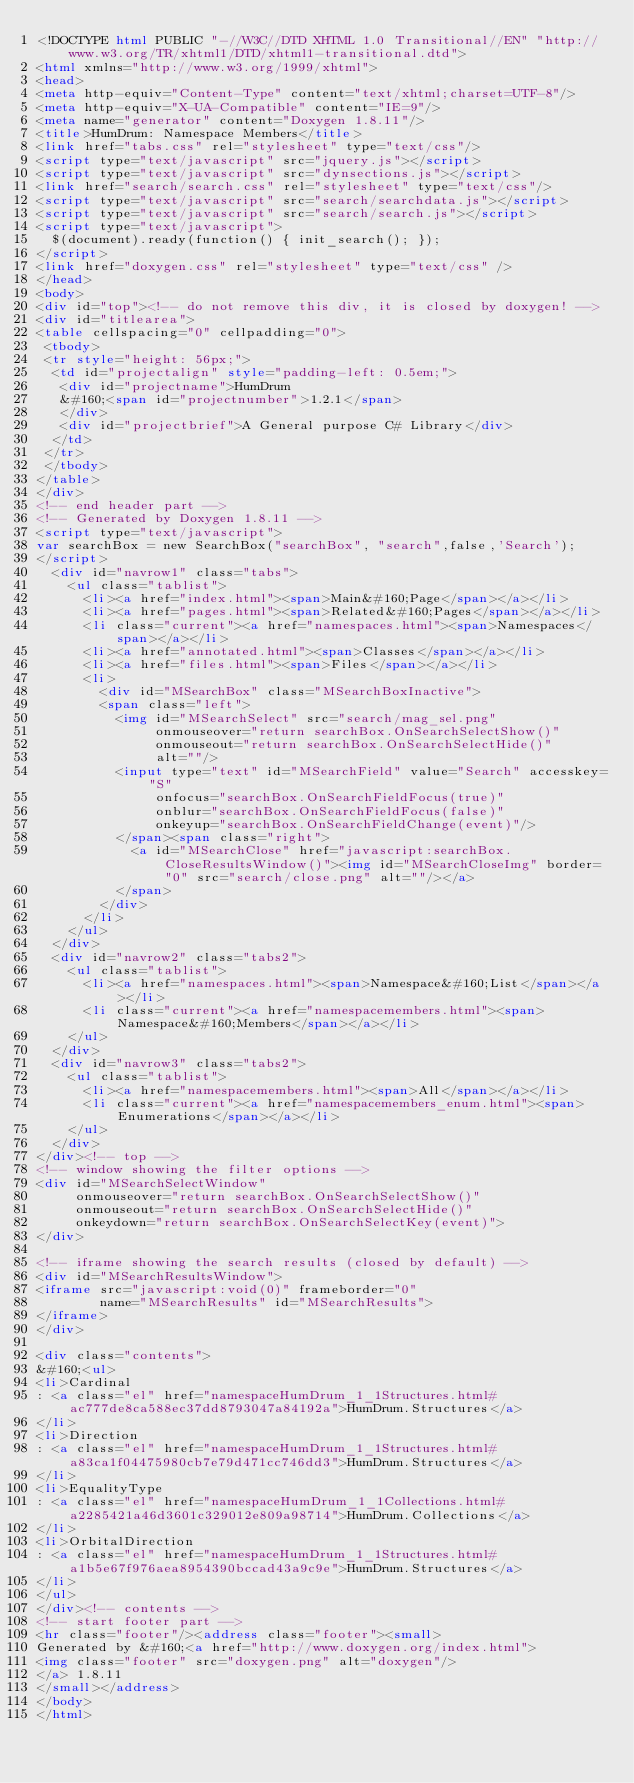Convert code to text. <code><loc_0><loc_0><loc_500><loc_500><_HTML_><!DOCTYPE html PUBLIC "-//W3C//DTD XHTML 1.0 Transitional//EN" "http://www.w3.org/TR/xhtml1/DTD/xhtml1-transitional.dtd">
<html xmlns="http://www.w3.org/1999/xhtml">
<head>
<meta http-equiv="Content-Type" content="text/xhtml;charset=UTF-8"/>
<meta http-equiv="X-UA-Compatible" content="IE=9"/>
<meta name="generator" content="Doxygen 1.8.11"/>
<title>HumDrum: Namespace Members</title>
<link href="tabs.css" rel="stylesheet" type="text/css"/>
<script type="text/javascript" src="jquery.js"></script>
<script type="text/javascript" src="dynsections.js"></script>
<link href="search/search.css" rel="stylesheet" type="text/css"/>
<script type="text/javascript" src="search/searchdata.js"></script>
<script type="text/javascript" src="search/search.js"></script>
<script type="text/javascript">
  $(document).ready(function() { init_search(); });
</script>
<link href="doxygen.css" rel="stylesheet" type="text/css" />
</head>
<body>
<div id="top"><!-- do not remove this div, it is closed by doxygen! -->
<div id="titlearea">
<table cellspacing="0" cellpadding="0">
 <tbody>
 <tr style="height: 56px;">
  <td id="projectalign" style="padding-left: 0.5em;">
   <div id="projectname">HumDrum
   &#160;<span id="projectnumber">1.2.1</span>
   </div>
   <div id="projectbrief">A General purpose C# Library</div>
  </td>
 </tr>
 </tbody>
</table>
</div>
<!-- end header part -->
<!-- Generated by Doxygen 1.8.11 -->
<script type="text/javascript">
var searchBox = new SearchBox("searchBox", "search",false,'Search');
</script>
  <div id="navrow1" class="tabs">
    <ul class="tablist">
      <li><a href="index.html"><span>Main&#160;Page</span></a></li>
      <li><a href="pages.html"><span>Related&#160;Pages</span></a></li>
      <li class="current"><a href="namespaces.html"><span>Namespaces</span></a></li>
      <li><a href="annotated.html"><span>Classes</span></a></li>
      <li><a href="files.html"><span>Files</span></a></li>
      <li>
        <div id="MSearchBox" class="MSearchBoxInactive">
        <span class="left">
          <img id="MSearchSelect" src="search/mag_sel.png"
               onmouseover="return searchBox.OnSearchSelectShow()"
               onmouseout="return searchBox.OnSearchSelectHide()"
               alt=""/>
          <input type="text" id="MSearchField" value="Search" accesskey="S"
               onfocus="searchBox.OnSearchFieldFocus(true)" 
               onblur="searchBox.OnSearchFieldFocus(false)" 
               onkeyup="searchBox.OnSearchFieldChange(event)"/>
          </span><span class="right">
            <a id="MSearchClose" href="javascript:searchBox.CloseResultsWindow()"><img id="MSearchCloseImg" border="0" src="search/close.png" alt=""/></a>
          </span>
        </div>
      </li>
    </ul>
  </div>
  <div id="navrow2" class="tabs2">
    <ul class="tablist">
      <li><a href="namespaces.html"><span>Namespace&#160;List</span></a></li>
      <li class="current"><a href="namespacemembers.html"><span>Namespace&#160;Members</span></a></li>
    </ul>
  </div>
  <div id="navrow3" class="tabs2">
    <ul class="tablist">
      <li><a href="namespacemembers.html"><span>All</span></a></li>
      <li class="current"><a href="namespacemembers_enum.html"><span>Enumerations</span></a></li>
    </ul>
  </div>
</div><!-- top -->
<!-- window showing the filter options -->
<div id="MSearchSelectWindow"
     onmouseover="return searchBox.OnSearchSelectShow()"
     onmouseout="return searchBox.OnSearchSelectHide()"
     onkeydown="return searchBox.OnSearchSelectKey(event)">
</div>

<!-- iframe showing the search results (closed by default) -->
<div id="MSearchResultsWindow">
<iframe src="javascript:void(0)" frameborder="0" 
        name="MSearchResults" id="MSearchResults">
</iframe>
</div>

<div class="contents">
&#160;<ul>
<li>Cardinal
: <a class="el" href="namespaceHumDrum_1_1Structures.html#ac777de8ca588ec37dd8793047a84192a">HumDrum.Structures</a>
</li>
<li>Direction
: <a class="el" href="namespaceHumDrum_1_1Structures.html#a83ca1f04475980cb7e79d471cc746dd3">HumDrum.Structures</a>
</li>
<li>EqualityType
: <a class="el" href="namespaceHumDrum_1_1Collections.html#a2285421a46d3601c329012e809a98714">HumDrum.Collections</a>
</li>
<li>OrbitalDirection
: <a class="el" href="namespaceHumDrum_1_1Structures.html#a1b5e67f976aea8954390bccad43a9c9e">HumDrum.Structures</a>
</li>
</ul>
</div><!-- contents -->
<!-- start footer part -->
<hr class="footer"/><address class="footer"><small>
Generated by &#160;<a href="http://www.doxygen.org/index.html">
<img class="footer" src="doxygen.png" alt="doxygen"/>
</a> 1.8.11
</small></address>
</body>
</html>
</code> 